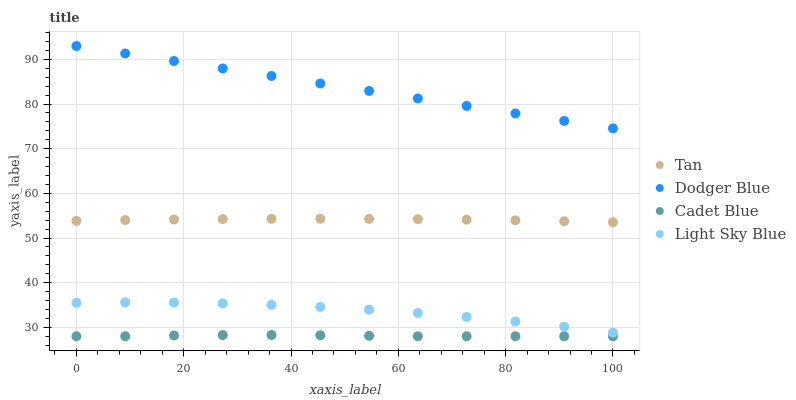Does Cadet Blue have the minimum area under the curve?
Answer yes or no. Yes. Does Dodger Blue have the maximum area under the curve?
Answer yes or no. Yes. Does Dodger Blue have the minimum area under the curve?
Answer yes or no. No. Does Cadet Blue have the maximum area under the curve?
Answer yes or no. No. Is Dodger Blue the smoothest?
Answer yes or no. Yes. Is Light Sky Blue the roughest?
Answer yes or no. Yes. Is Cadet Blue the smoothest?
Answer yes or no. No. Is Cadet Blue the roughest?
Answer yes or no. No. Does Cadet Blue have the lowest value?
Answer yes or no. Yes. Does Dodger Blue have the lowest value?
Answer yes or no. No. Does Dodger Blue have the highest value?
Answer yes or no. Yes. Does Cadet Blue have the highest value?
Answer yes or no. No. Is Cadet Blue less than Dodger Blue?
Answer yes or no. Yes. Is Dodger Blue greater than Cadet Blue?
Answer yes or no. Yes. Does Cadet Blue intersect Dodger Blue?
Answer yes or no. No. 